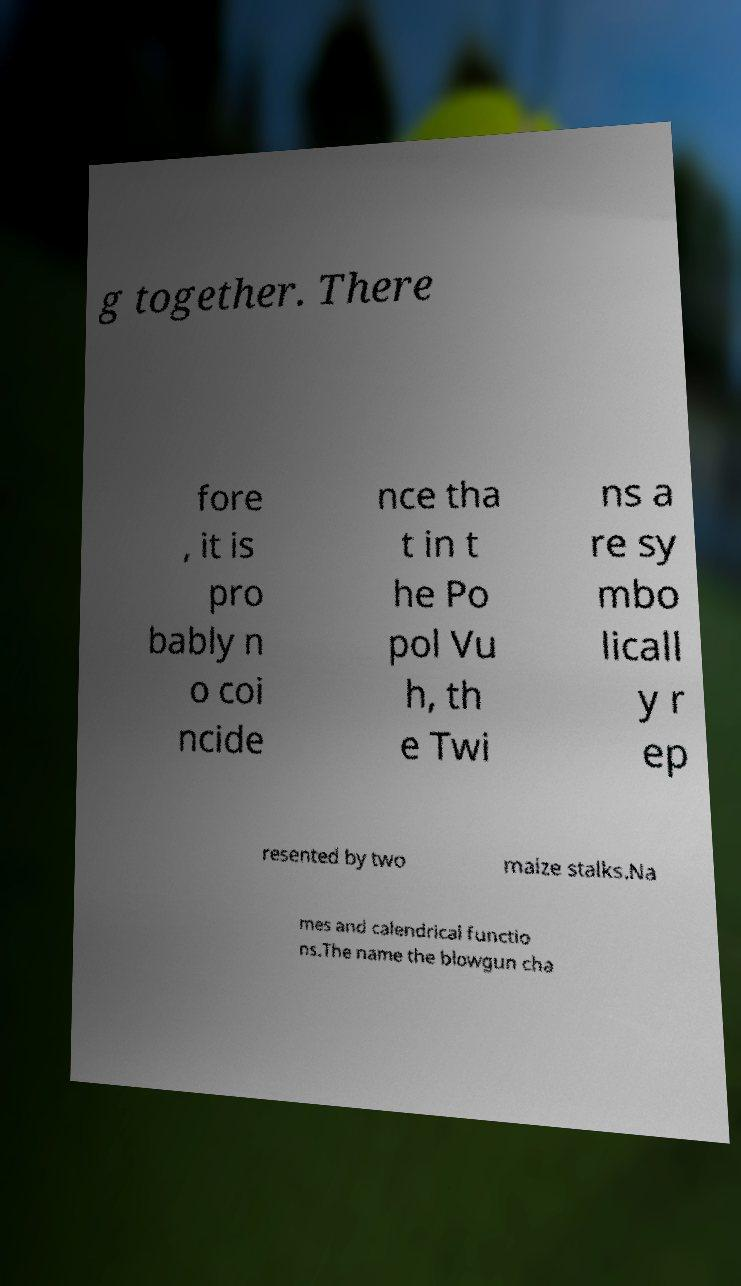Could you extract and type out the text from this image? g together. There fore , it is pro bably n o coi ncide nce tha t in t he Po pol Vu h, th e Twi ns a re sy mbo licall y r ep resented by two maize stalks.Na mes and calendrical functio ns.The name the blowgun cha 